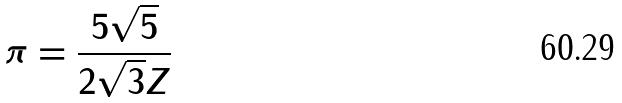<formula> <loc_0><loc_0><loc_500><loc_500>\pi = \frac { 5 \sqrt { 5 } } { 2 \sqrt { 3 } Z }</formula> 